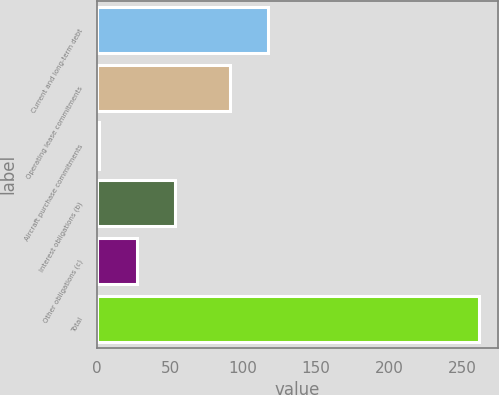Convert chart. <chart><loc_0><loc_0><loc_500><loc_500><bar_chart><fcel>Current and long-term debt<fcel>Operating lease commitments<fcel>Aircraft purchase commitments<fcel>Interest obligations (b)<fcel>Other obligations (c)<fcel>Total<nl><fcel>116.82<fcel>90.8<fcel>1.4<fcel>53.44<fcel>27.42<fcel>261.6<nl></chart> 